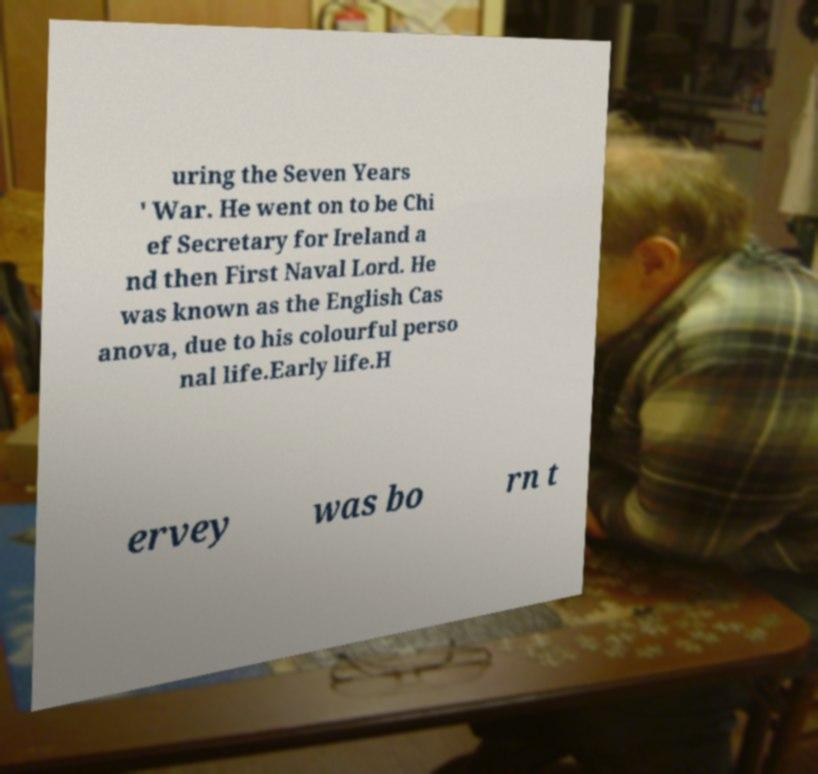There's text embedded in this image that I need extracted. Can you transcribe it verbatim? uring the Seven Years ' War. He went on to be Chi ef Secretary for Ireland a nd then First Naval Lord. He was known as the English Cas anova, due to his colourful perso nal life.Early life.H ervey was bo rn t 